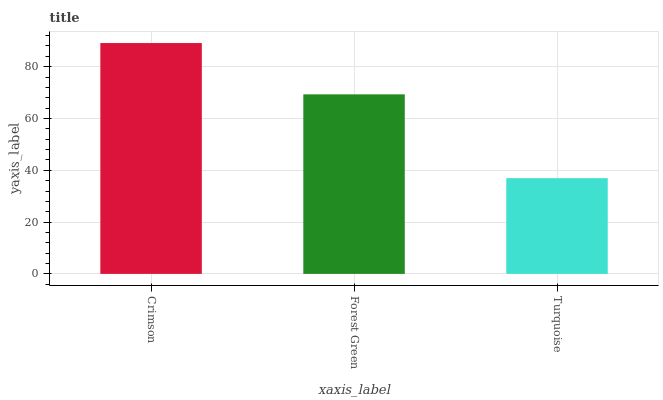Is Turquoise the minimum?
Answer yes or no. Yes. Is Crimson the maximum?
Answer yes or no. Yes. Is Forest Green the minimum?
Answer yes or no. No. Is Forest Green the maximum?
Answer yes or no. No. Is Crimson greater than Forest Green?
Answer yes or no. Yes. Is Forest Green less than Crimson?
Answer yes or no. Yes. Is Forest Green greater than Crimson?
Answer yes or no. No. Is Crimson less than Forest Green?
Answer yes or no. No. Is Forest Green the high median?
Answer yes or no. Yes. Is Forest Green the low median?
Answer yes or no. Yes. Is Crimson the high median?
Answer yes or no. No. Is Crimson the low median?
Answer yes or no. No. 